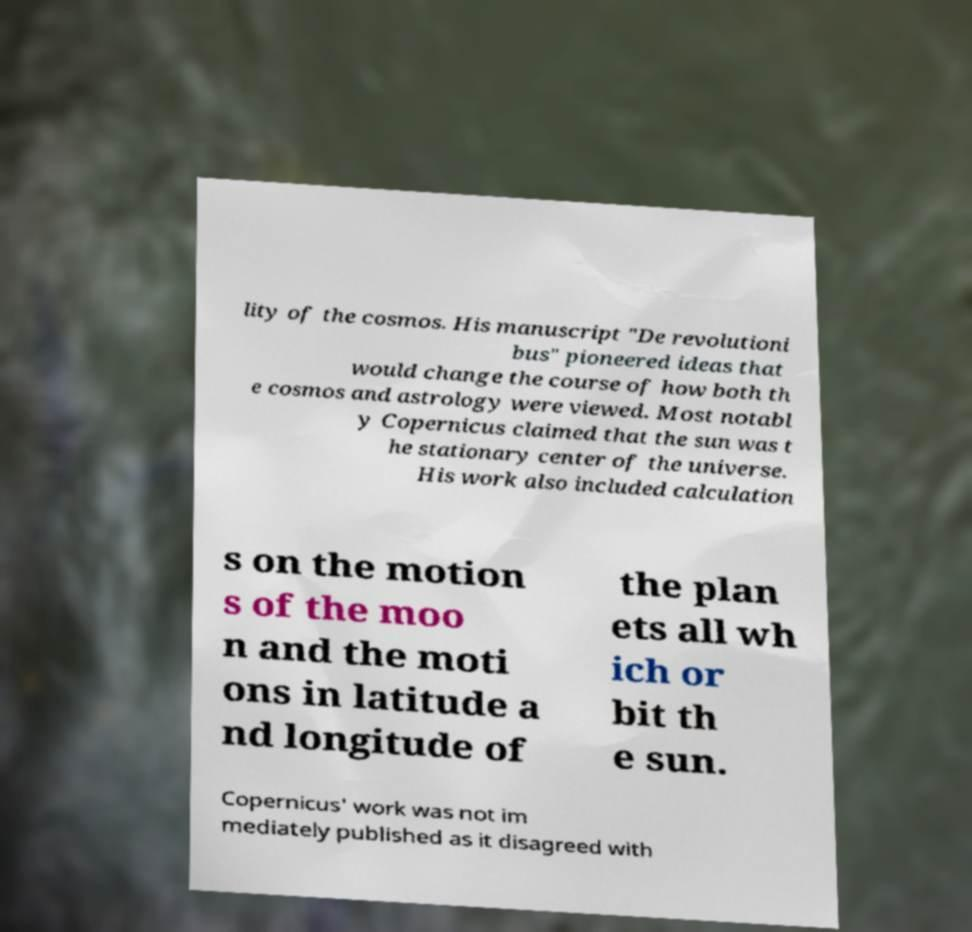Can you read and provide the text displayed in the image?This photo seems to have some interesting text. Can you extract and type it out for me? lity of the cosmos. His manuscript "De revolutioni bus" pioneered ideas that would change the course of how both th e cosmos and astrology were viewed. Most notabl y Copernicus claimed that the sun was t he stationary center of the universe. His work also included calculation s on the motion s of the moo n and the moti ons in latitude a nd longitude of the plan ets all wh ich or bit th e sun. Copernicus' work was not im mediately published as it disagreed with 